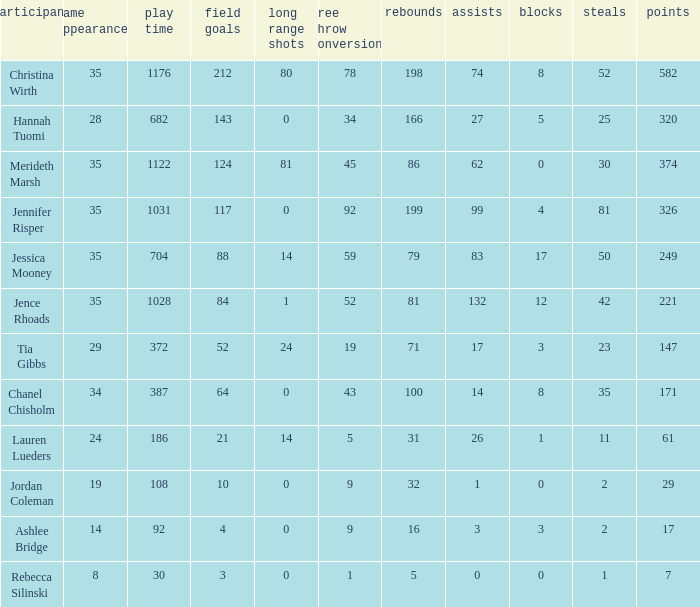For how long did Jordan Coleman play? 108.0. 